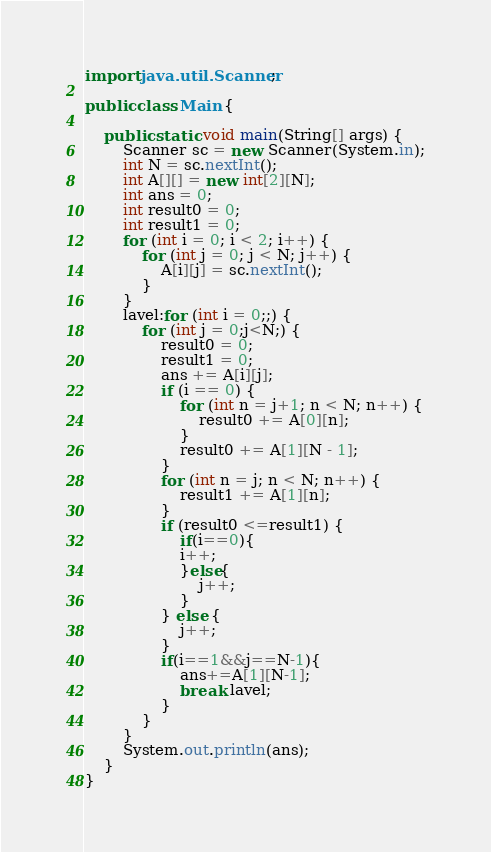<code> <loc_0><loc_0><loc_500><loc_500><_Java_>import java.util.Scanner;

public class Main {

    public static void main(String[] args) {
        Scanner sc = new Scanner(System.in);
        int N = sc.nextInt();
        int A[][] = new int[2][N];
        int ans = 0;
        int result0 = 0;
        int result1 = 0;
        for (int i = 0; i < 2; i++) {
            for (int j = 0; j < N; j++) {
                A[i][j] = sc.nextInt();
            }
        }
        lavel:for (int i = 0;;) {
            for (int j = 0;j<N;) {
                result0 = 0;
                result1 = 0;
                ans += A[i][j];
                if (i == 0) {
                    for (int n = j+1; n < N; n++) {
                        result0 += A[0][n];
                    }
                    result0 += A[1][N - 1];
                }
                for (int n = j; n < N; n++) {
                    result1 += A[1][n];
                }
                if (result0 <=result1) {
                    if(i==0){
                    i++;
                    }else{
                        j++;
                    }
                } else {
                    j++;
                }
                if(i==1&&j==N-1){
                    ans+=A[1][N-1];
                    break lavel;
                }
            }
        }
        System.out.println(ans);
    }
}</code> 